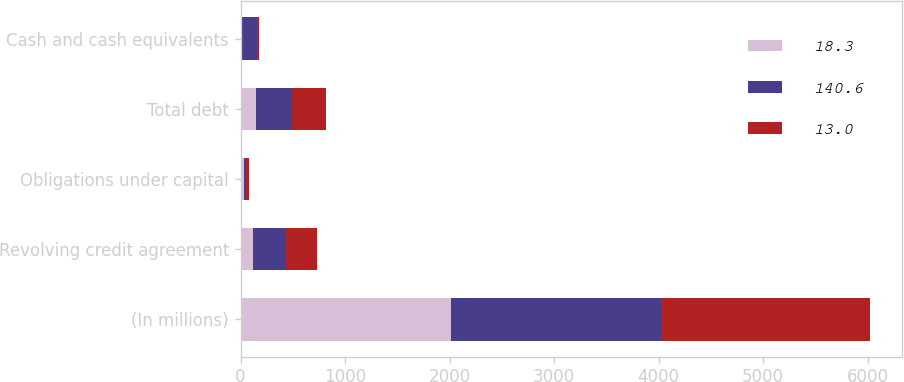Convert chart. <chart><loc_0><loc_0><loc_500><loc_500><stacked_bar_chart><ecel><fcel>(In millions)<fcel>Revolving credit agreement<fcel>Obligations under capital<fcel>Total debt<fcel>Cash and cash equivalents<nl><fcel>18.3<fcel>2010<fcel>122.5<fcel>28.1<fcel>150.6<fcel>18.3<nl><fcel>140.6<fcel>2009<fcel>308.5<fcel>28.6<fcel>337<fcel>140.6<nl><fcel>13<fcel>2008<fcel>300.2<fcel>27.6<fcel>327.8<fcel>13<nl></chart> 